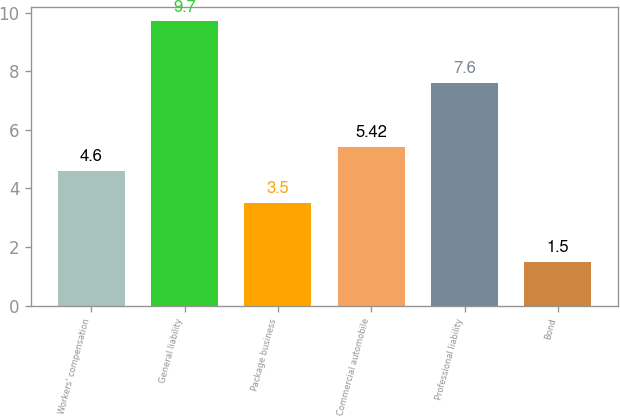<chart> <loc_0><loc_0><loc_500><loc_500><bar_chart><fcel>Workers' compensation<fcel>General liability<fcel>Package business<fcel>Commercial automobile<fcel>Professional liability<fcel>Bond<nl><fcel>4.6<fcel>9.7<fcel>3.5<fcel>5.42<fcel>7.6<fcel>1.5<nl></chart> 